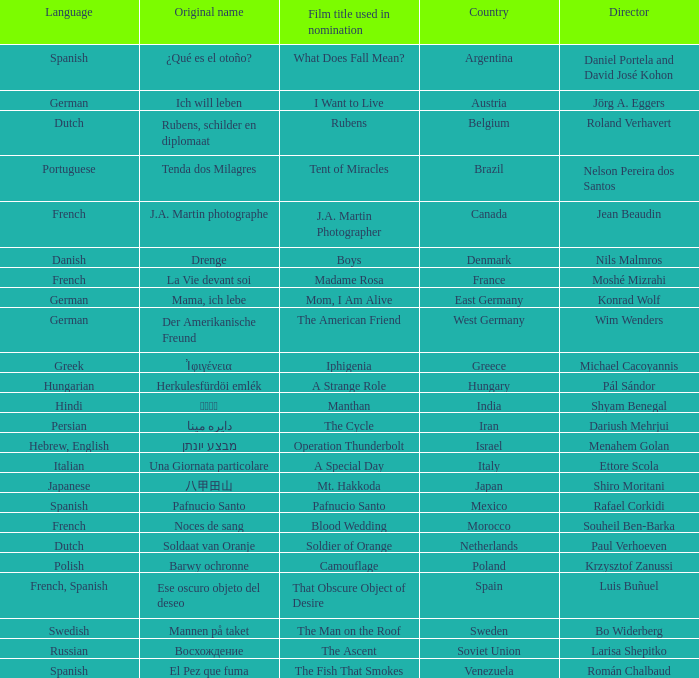Could you parse the entire table as a dict? {'header': ['Language', 'Original name', 'Film title used in nomination', 'Country', 'Director'], 'rows': [['Spanish', '¿Qué es el otoño?', 'What Does Fall Mean?', 'Argentina', 'Daniel Portela and David José Kohon'], ['German', 'Ich will leben', 'I Want to Live', 'Austria', 'Jörg A. Eggers'], ['Dutch', 'Rubens, schilder en diplomaat', 'Rubens', 'Belgium', 'Roland Verhavert'], ['Portuguese', 'Tenda dos Milagres', 'Tent of Miracles', 'Brazil', 'Nelson Pereira dos Santos'], ['French', 'J.A. Martin photographe', 'J.A. Martin Photographer', 'Canada', 'Jean Beaudin'], ['Danish', 'Drenge', 'Boys', 'Denmark', 'Nils Malmros'], ['French', 'La Vie devant soi', 'Madame Rosa', 'France', 'Moshé Mizrahi'], ['German', 'Mama, ich lebe', 'Mom, I Am Alive', 'East Germany', 'Konrad Wolf'], ['German', 'Der Amerikanische Freund', 'The American Friend', 'West Germany', 'Wim Wenders'], ['Greek', 'Ἰφιγένεια', 'Iphigenia', 'Greece', 'Michael Cacoyannis'], ['Hungarian', 'Herkulesfürdöi emlék', 'A Strange Role', 'Hungary', 'Pál Sándor'], ['Hindi', 'मंथन', 'Manthan', 'India', 'Shyam Benegal'], ['Persian', 'دايره مينا', 'The Cycle', 'Iran', 'Dariush Mehrjui'], ['Hebrew, English', 'מבצע יונתן', 'Operation Thunderbolt', 'Israel', 'Menahem Golan'], ['Italian', 'Una Giornata particolare', 'A Special Day', 'Italy', 'Ettore Scola'], ['Japanese', '八甲田山', 'Mt. Hakkoda', 'Japan', 'Shiro Moritani'], ['Spanish', 'Pafnucio Santo', 'Pafnucio Santo', 'Mexico', 'Rafael Corkidi'], ['French', 'Noces de sang', 'Blood Wedding', 'Morocco', 'Souheil Ben-Barka'], ['Dutch', 'Soldaat van Oranje', 'Soldier of Orange', 'Netherlands', 'Paul Verhoeven'], ['Polish', 'Barwy ochronne', 'Camouflage', 'Poland', 'Krzysztof Zanussi'], ['French, Spanish', 'Ese oscuro objeto del deseo', 'That Obscure Object of Desire', 'Spain', 'Luis Buñuel'], ['Swedish', 'Mannen på taket', 'The Man on the Roof', 'Sweden', 'Bo Widerberg'], ['Russian', 'Восхождение', 'The Ascent', 'Soviet Union', 'Larisa Shepitko'], ['Spanish', 'El Pez que fuma', 'The Fish That Smokes', 'Venezuela', 'Román Chalbaud']]} Which director is from Italy? Ettore Scola. 